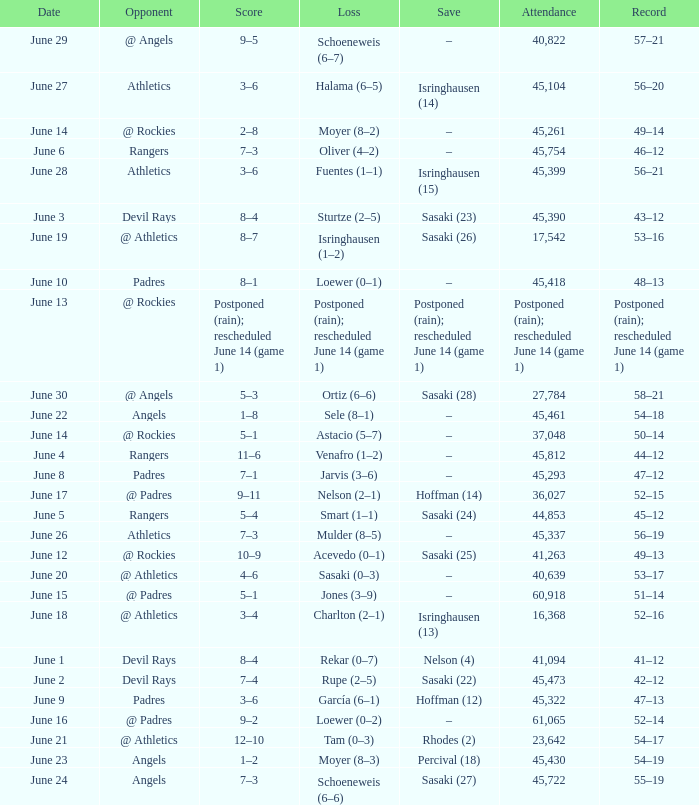What was the attendance of the Mariners game when they had a record of 56–20? 45104.0. 